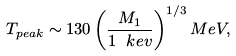Convert formula to latex. <formula><loc_0><loc_0><loc_500><loc_500>T _ { p e a k } \sim 1 3 0 \left ( \frac { M _ { 1 } } { 1 \ k e v } \right ) ^ { 1 / 3 } M e V ,</formula> 